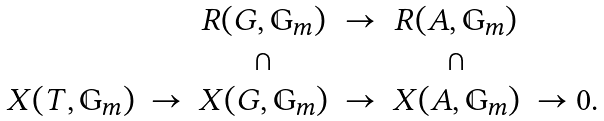<formula> <loc_0><loc_0><loc_500><loc_500>\begin{matrix} & & & R ( G , \mathbb { G } _ { m } ) & \to & R ( A , \mathbb { G } _ { m } ) & \\ & & & \cap & & \cap & \\ & X ( T , \mathbb { G } _ { m } ) & \to & X ( G , \mathbb { G } _ { m } ) & \to & X ( A , \mathbb { G } _ { m } ) & \to 0 . \end{matrix}</formula> 